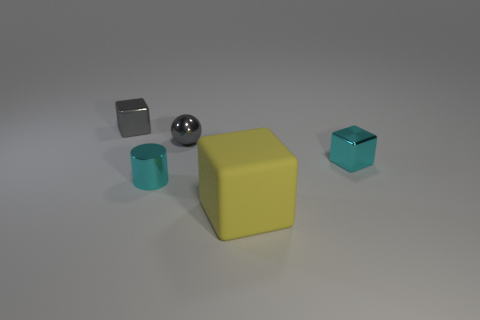What could be the materials of the objects and how could you use that information? The sphere and the small cube give the impression of metallic surfaces, with the sphere showcasing a polished finish and the cube a matte one. The large cube seems like it may be made of a plastic or rubber material, given its opaque and matte finish. The cylindrical cup and the small teal cube appear ceramic or glass-like due to their reflective qualities. Recognizing these materials is beneficial for understanding the objects’ potential uses, the light interactions for photography or rendering, or for educational purposes in material science. 